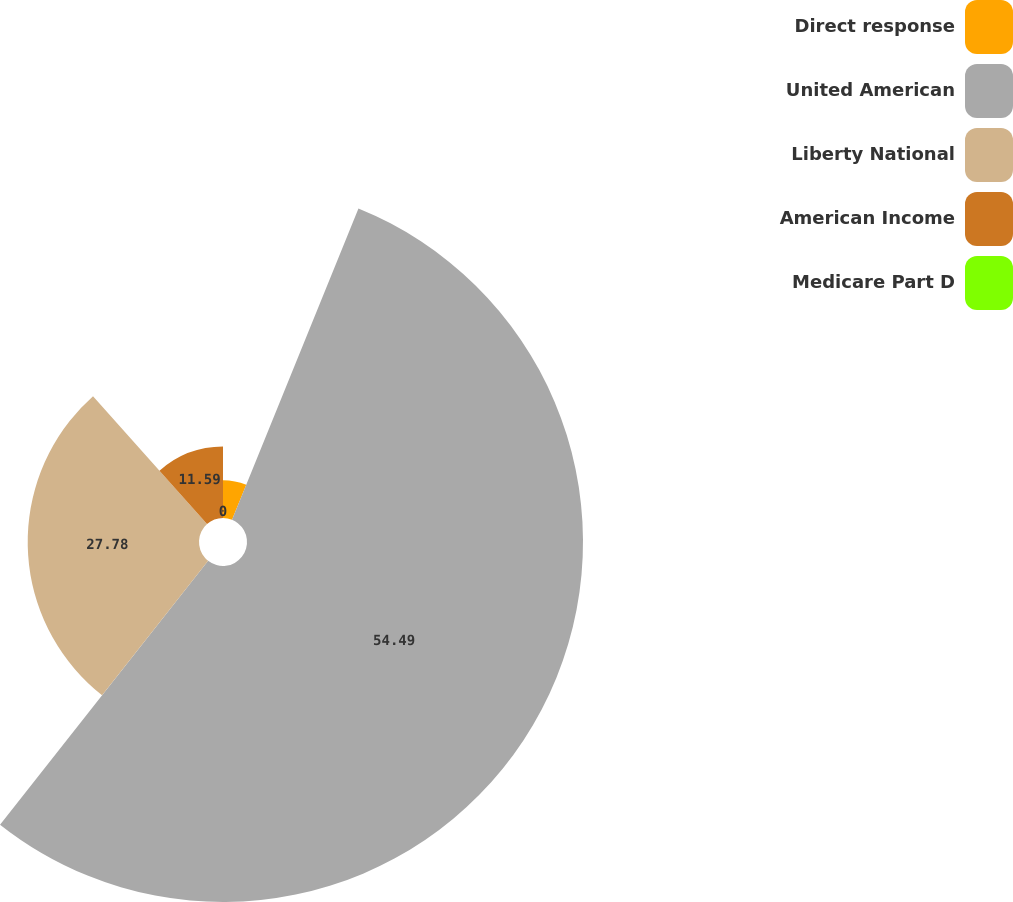Convert chart. <chart><loc_0><loc_0><loc_500><loc_500><pie_chart><fcel>Direct response<fcel>United American<fcel>Liberty National<fcel>American Income<fcel>Medicare Part D<nl><fcel>6.14%<fcel>54.49%<fcel>27.78%<fcel>11.59%<fcel>0.0%<nl></chart> 